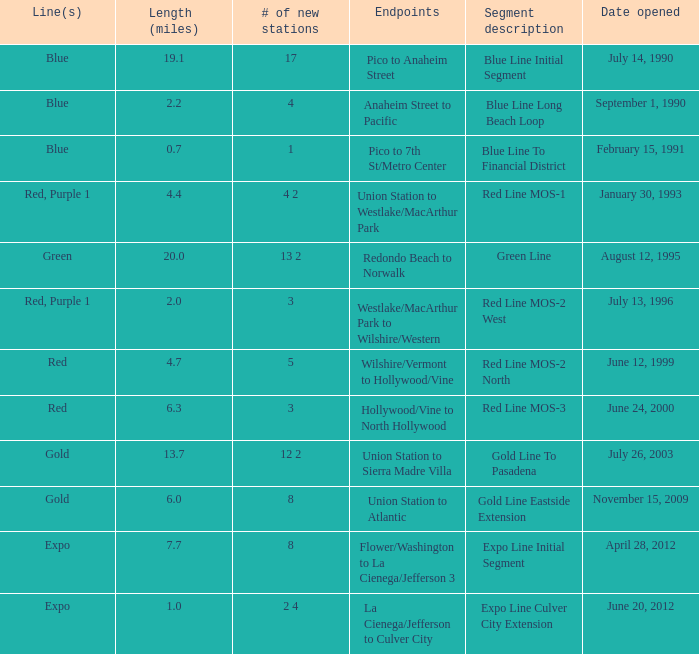How many lines have the segment description of red line mos-2 west? Red, Purple 1. 